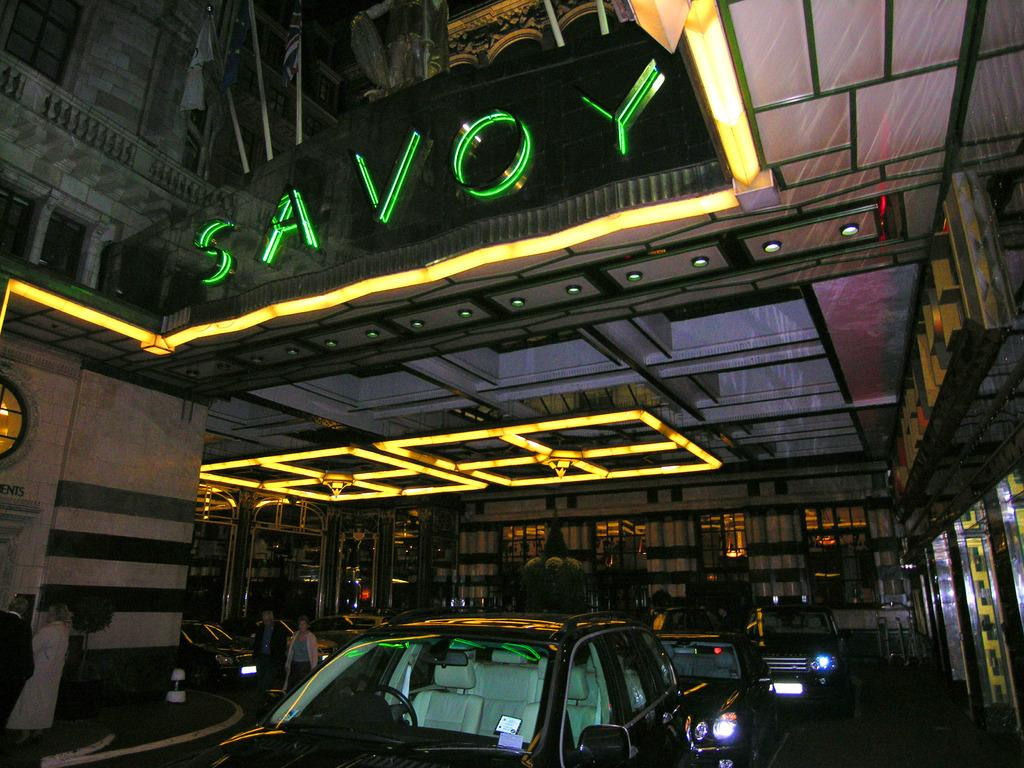<image>
Render a clear and concise summary of the photo. A carport that has the word Savoy above it in neon lighting. 